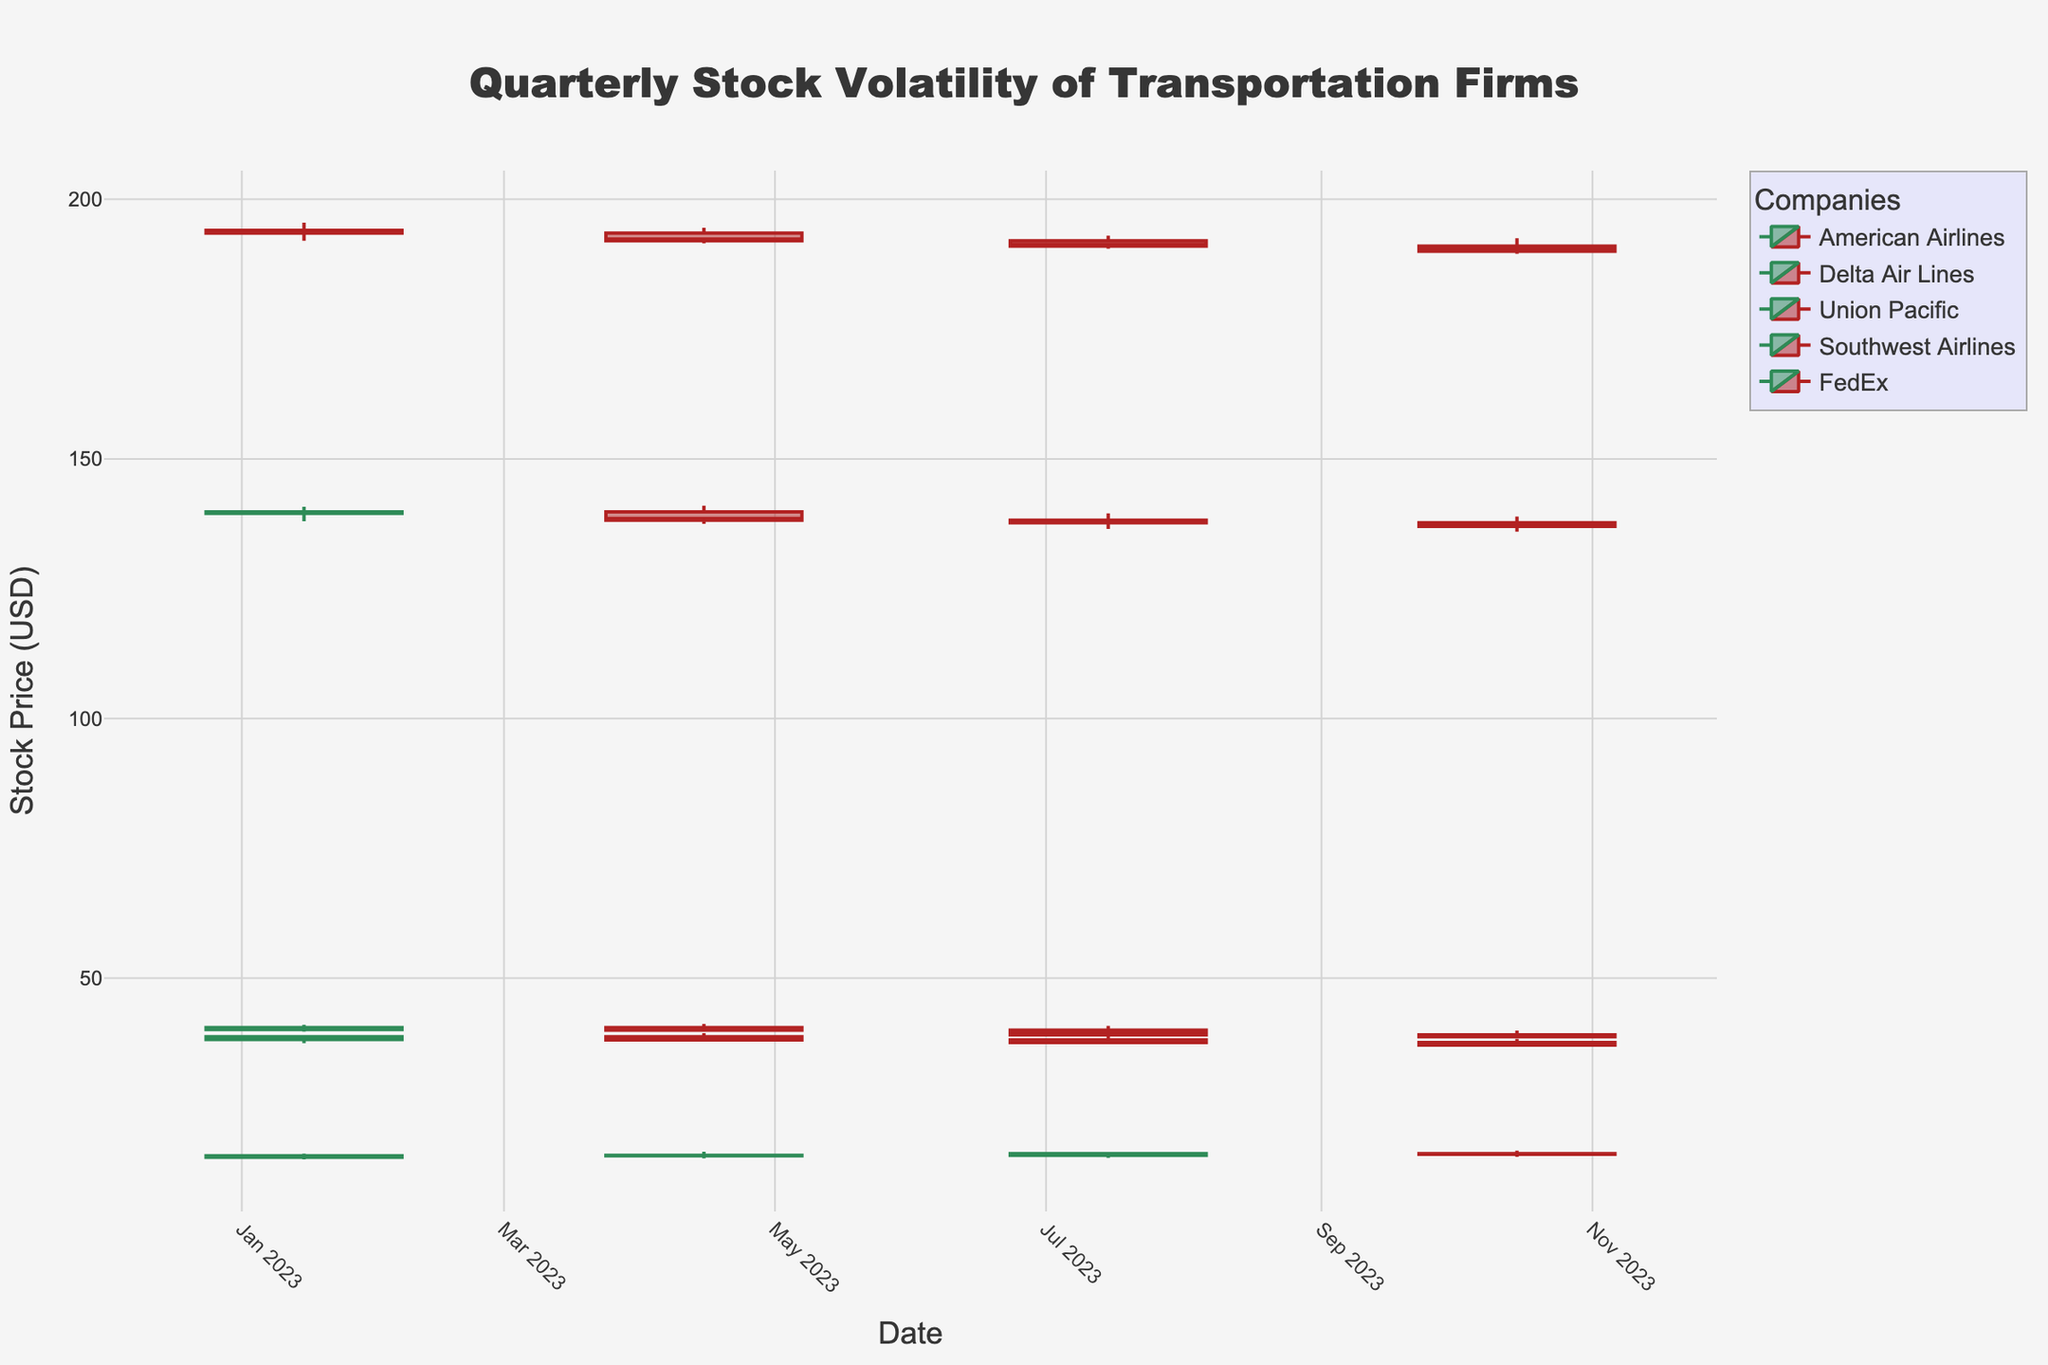What is the closing price of American Airlines on April 15, 2023? The chart has clearly marked closing prices for each company on specific dates. Look for the candlestick for American Airlines on April 15, 2023, and note the closing price.
Answer: 15.90 How did the closing price of Delta Air Lines change from January 15, 2023, to October 15, 2023? Examine the closing prices on both dates and calculate the difference. For January 15, it's 38.70, and for October 15, it's 37.10. The change is 37.10 - 38.70.
Answer: -1.60 Among the listed companies, which one had the smallest range (difference between high and low prices) on July 15, 2023? Identify the high and low prices for each company on July 15, 2023, calculate the range for each, and compare.
Answer: Delta Air Lines What is the average opening price of FedEx across all quarters shown? Sum the opening prices for FedEx on each of the provided dates and divide by the number of quarters. The prices are 139.50, 139.80, 138.20, and 137.70. So, the average is (139.50 + 139.80 + 138.20 + 137.70)/4.
Answer: 138.80 Which company had the highest closing price on January 15, 2023, and what was it? Review the closing prices for all companies on January 15, 2023, and identify the highest one.
Answer: Union Pacific, 193.50 What's the trend of the closing prices for Southwest Airlines from January to October 2023? Observe the closing prices for Southwest Airlines on each date, noting whether they increase, decrease, or stay the same. The prices are 40.50, 40.00, 39.10, and 38.70, respectively.
Answer: Downward Which company's stock had the most visible increase in closing price between any two consecutive quarters? Compare the closing prices of each company between each consecutive quarter and identify the greatest increase.
Answer: American Airlines from July to October Is there any quarter where all companies had a decrease in closing price compared to the previous quarter? If yes, which quarter? Compare each company's closing price quarter by quarter to see if all show a decrease in any quarter.
Answer: July 2023 to October 2023 What is the total trading volume for Delta Air Lines over the four quarters shown? Add up the trading volumes for Delta Air Lines for each quarter. The volumes are 4200000, 4100000, 4000000, and 3900000.
Answer: 16200000 